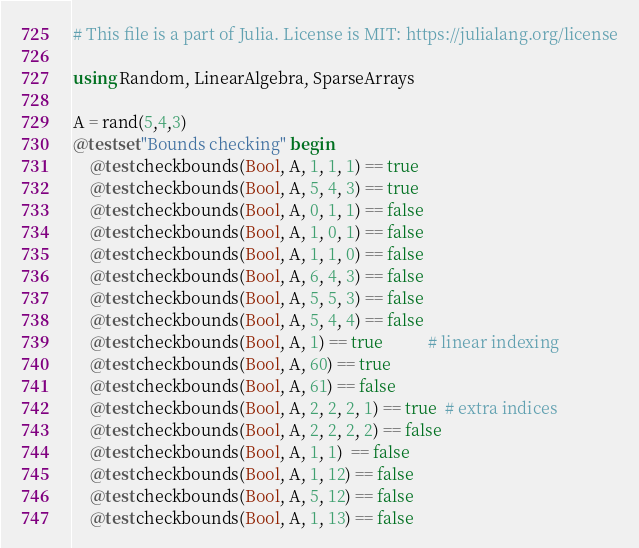Convert code to text. <code><loc_0><loc_0><loc_500><loc_500><_Julia_># This file is a part of Julia. License is MIT: https://julialang.org/license

using Random, LinearAlgebra, SparseArrays

A = rand(5,4,3)
@testset "Bounds checking" begin
    @test checkbounds(Bool, A, 1, 1, 1) == true
    @test checkbounds(Bool, A, 5, 4, 3) == true
    @test checkbounds(Bool, A, 0, 1, 1) == false
    @test checkbounds(Bool, A, 1, 0, 1) == false
    @test checkbounds(Bool, A, 1, 1, 0) == false
    @test checkbounds(Bool, A, 6, 4, 3) == false
    @test checkbounds(Bool, A, 5, 5, 3) == false
    @test checkbounds(Bool, A, 5, 4, 4) == false
    @test checkbounds(Bool, A, 1) == true           # linear indexing
    @test checkbounds(Bool, A, 60) == true
    @test checkbounds(Bool, A, 61) == false
    @test checkbounds(Bool, A, 2, 2, 2, 1) == true  # extra indices
    @test checkbounds(Bool, A, 2, 2, 2, 2) == false
    @test checkbounds(Bool, A, 1, 1)  == false
    @test checkbounds(Bool, A, 1, 12) == false
    @test checkbounds(Bool, A, 5, 12) == false
    @test checkbounds(Bool, A, 1, 13) == false</code> 